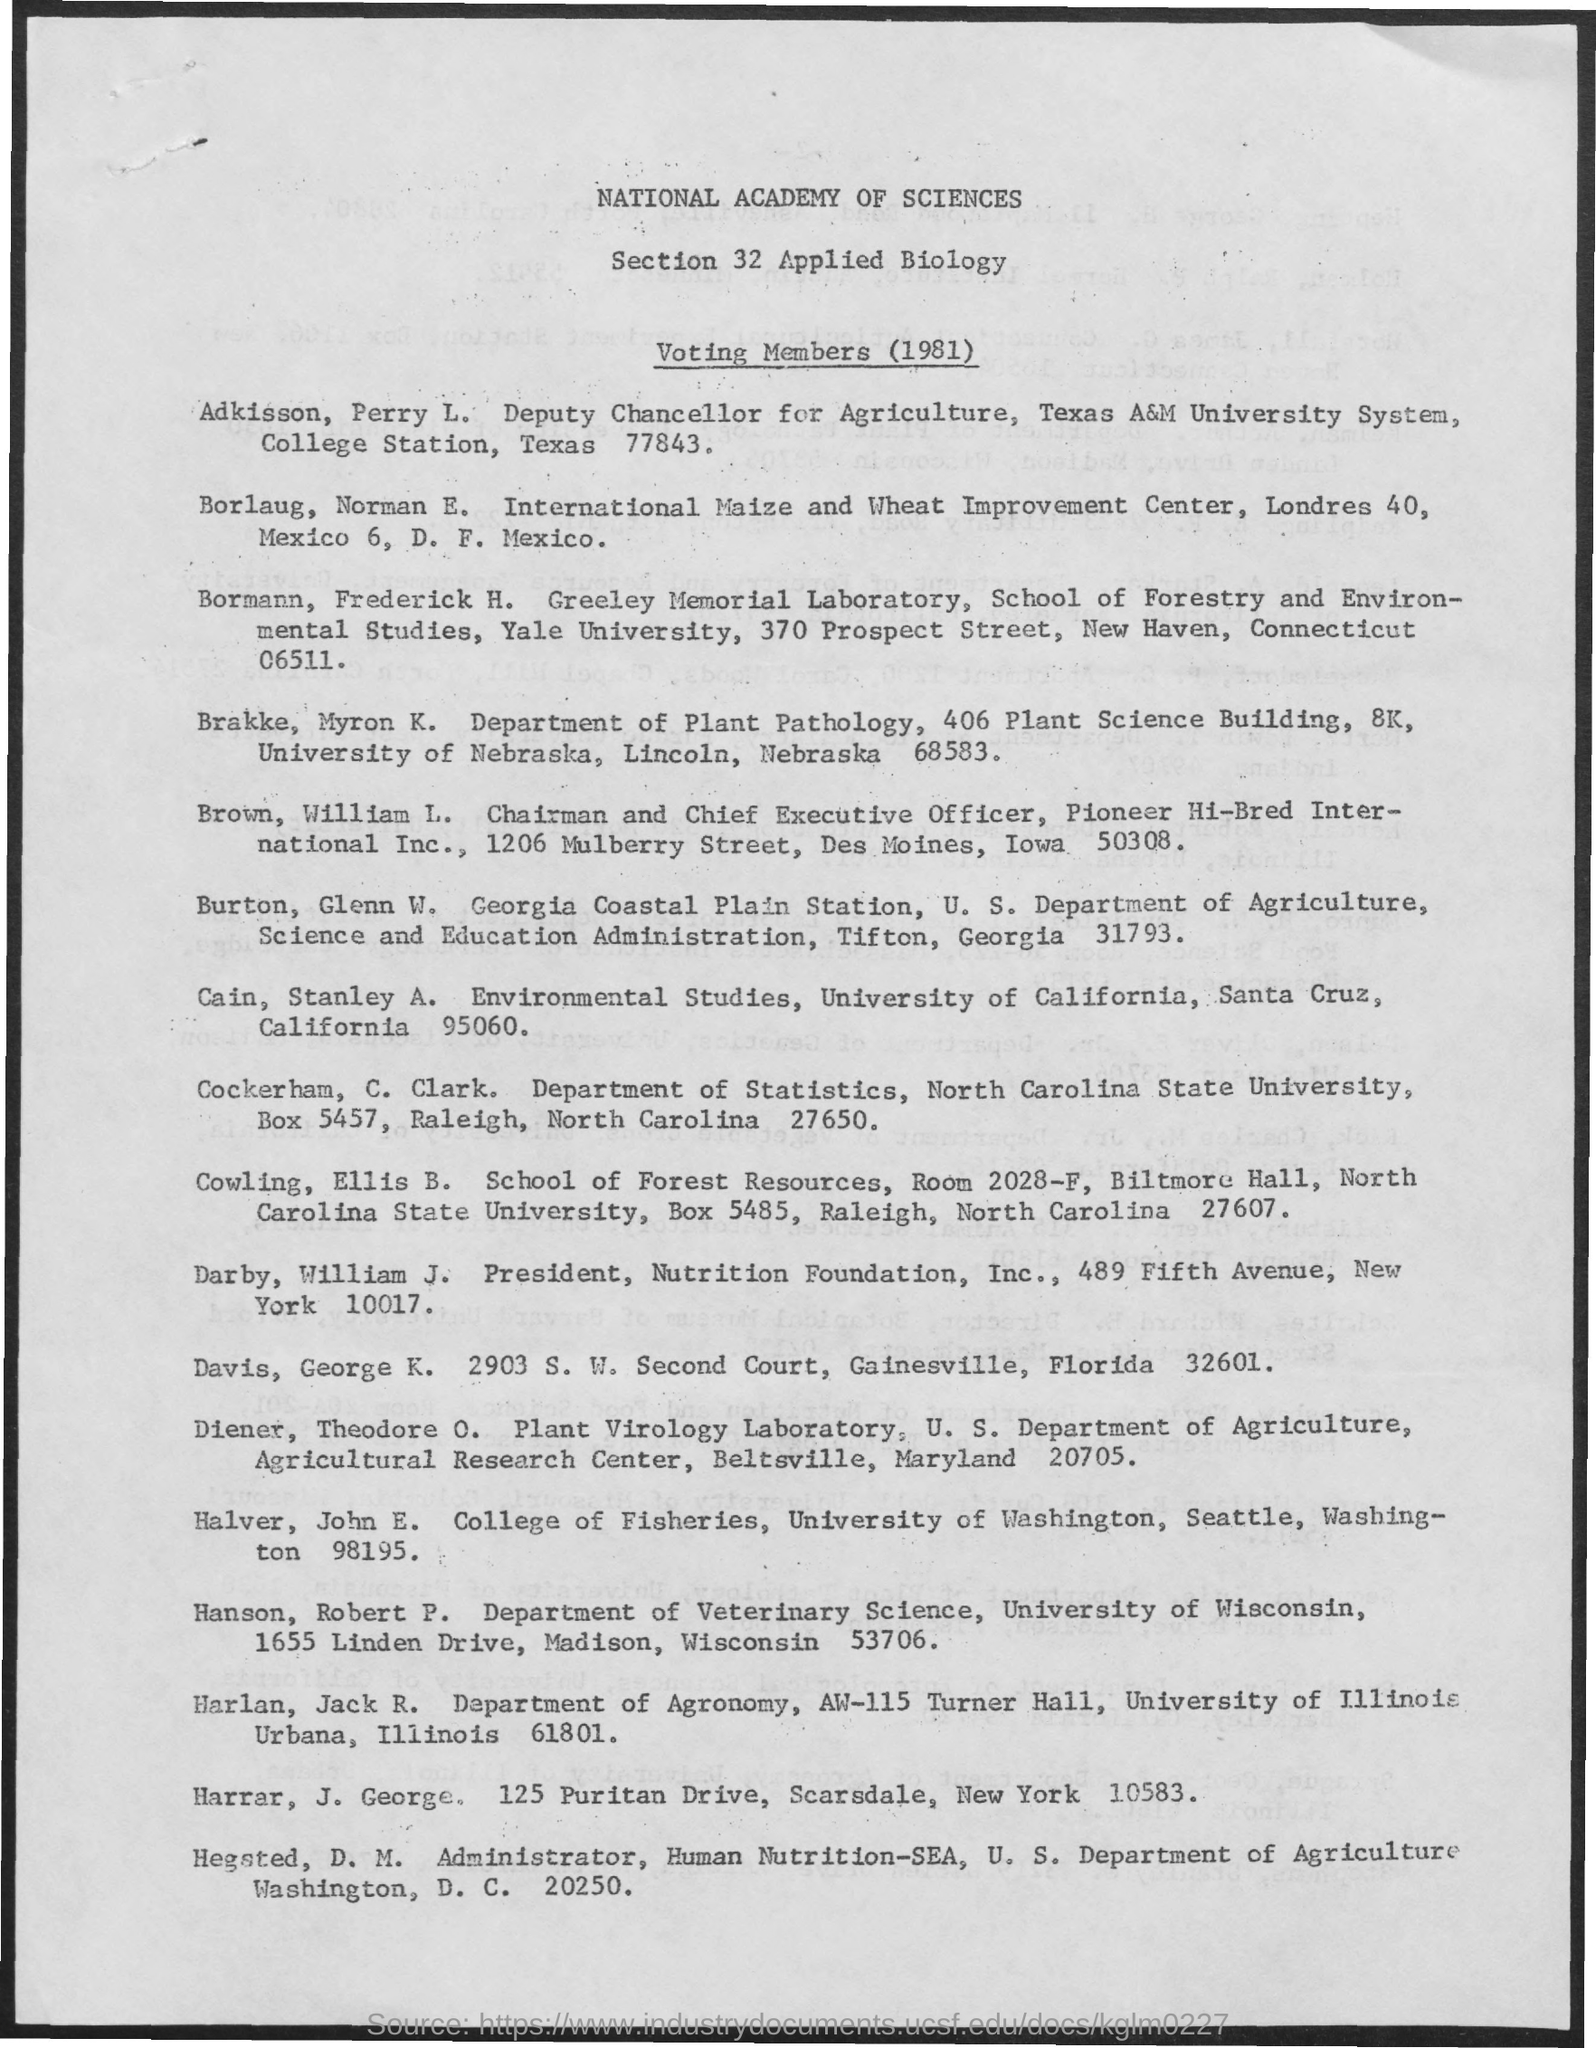Identify some key points in this picture. The specific details regarding the voting members for the year 1981 are currently unknown. Adkisson Perry L. is the Deputy Chancellor of Agriculture. 